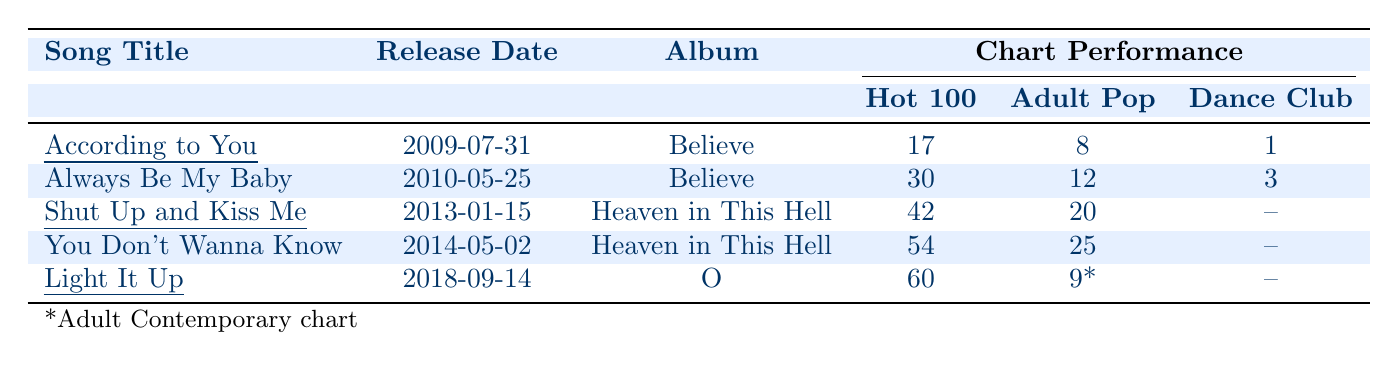What is the release date of "According to You"? The table lists the release date of the song "According to You" as 2009-07-31.
Answer: 2009-07-31 Which song had the highest chart position in the US Hot Dance Club Songs? The song "According to You" achieved the highest position on the US Hot Dance Club Songs chart, reaching number 1.
Answer: According to You How many songs released after 2013 reached the Top 30 in the US Billboard Hot 100? The songs released after 2013 are "You Don’t Wanna Know" (54) and "Light It Up" (60); neither reached the Top 30 on the US Billboard Hot 100.
Answer: 0 Which album had two songs listed in the table, and what are their titles? The album "Believe" had two songs listed: "According to You" and "Always Be My Baby."
Answer: Believe, According to You and Always Be My Baby What is the average chart position for the song "Light It Up" across the provided charts? The chart positions for "Light It Up" are Hot 100 (60) and Adult Contemporary (9); the average is calculated as (60 + 9) / 2 = 34.5.
Answer: 34.5 Did "Shut Up and Kiss Me" make it to the US Hot Dance Club Songs chart? No, the song "Shut Up and Kiss Me" does not have a ranking in the US Hot Dance Club Songs chart as it is not listed.
Answer: No Which song has the highest position on both the US Billboard Hot 100 and US Adult Pop Songs? "According to You" holds the highest positions of 17 on the US Billboard Hot 100 and 8 on the US Adult Pop Songs.
Answer: According to You If you consider the top two chart rankings from the songs listed, which chart position is the lowest among them? The lowest chart position among the top two rankings is from "Always Be My Baby" at number 30 on the US Billboard Hot 100.
Answer: 30 Which song had no ranking on the US Hot Dance Club Songs chart? The songs "Shut Up and Kiss Me," "You Don't Wanna Know," and "Light It Up" had no ranking on the US Hot Dance Club Songs chart.
Answer: Shut Up and Kiss Me, You Don't Wanna Know, Light It Up What is the chart performance for "You Don’t Wanna Know" on US Adult Pop Songs? "You Don’t Wanna Know" reached number 25 on the US Adult Pop Songs chart.
Answer: 25 How many total songs are listed in the table? There are 5 songs listed in the table.
Answer: 5 